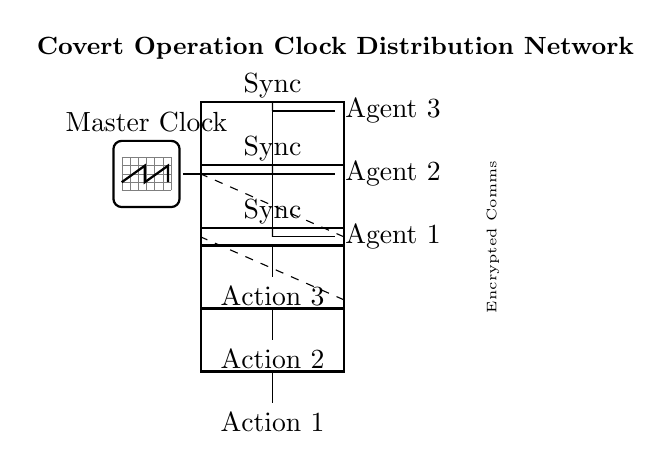What is the function of the master clock? The master clock serves as the timing reference for synchronizing the actions of multiple agents in the covert operation. Its role is essential in ensuring that all agents act in a coordinated manner.
Answer: Timing reference How many agents are connected to the clock distribution network? There are three agents connected to the network as indicated by the nodes labeled Agent 1, Agent 2, and Agent 3 in the diagram.
Answer: Three agents What does the dashed line represent in the circuit? The dashed line represents the encrypted communication lines between the synchronization blocks of the agents. This indicates that the communication between agents is secure and not easily intercepted.
Answer: Encrypted communication What is the purpose of the synchronization blocks? The synchronization blocks act as intermediaries to ensure that each agent receives the clock signal reliably and can execute their actions in sync with the master clock's timing. They ensure that the agents' actions are coordinated.
Answer: Coordinated timing Which action corresponds to Agent 2? The action corresponding to Agent 2 is labeled "Action 2" in the diagram, showing that it is the task assigned specifically for that agent based on the clock's timing.
Answer: Action 2 How are the synchronization blocks connected to the agents? The synchronization blocks are connected to the agents through direct lines that indicate the transfer of the clock signal, facilitating the agents' actions based on the synchronized timing.
Answer: Direct lines What does the label "Covert Operation Clock Distribution Network" signify? This label indicates the overall purpose of the circuit, highlighting that the clock distribution network is specifically designed for a covert operation, emphasizing the need for secrecy and coordination.
Answer: Covert operation 